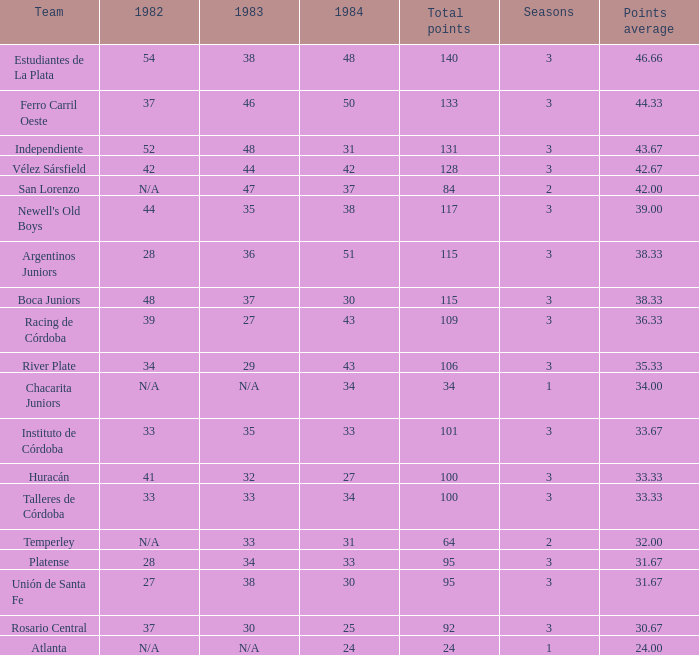What team had 3 seasons and fewer than 27 in 1984? Rosario Central. 